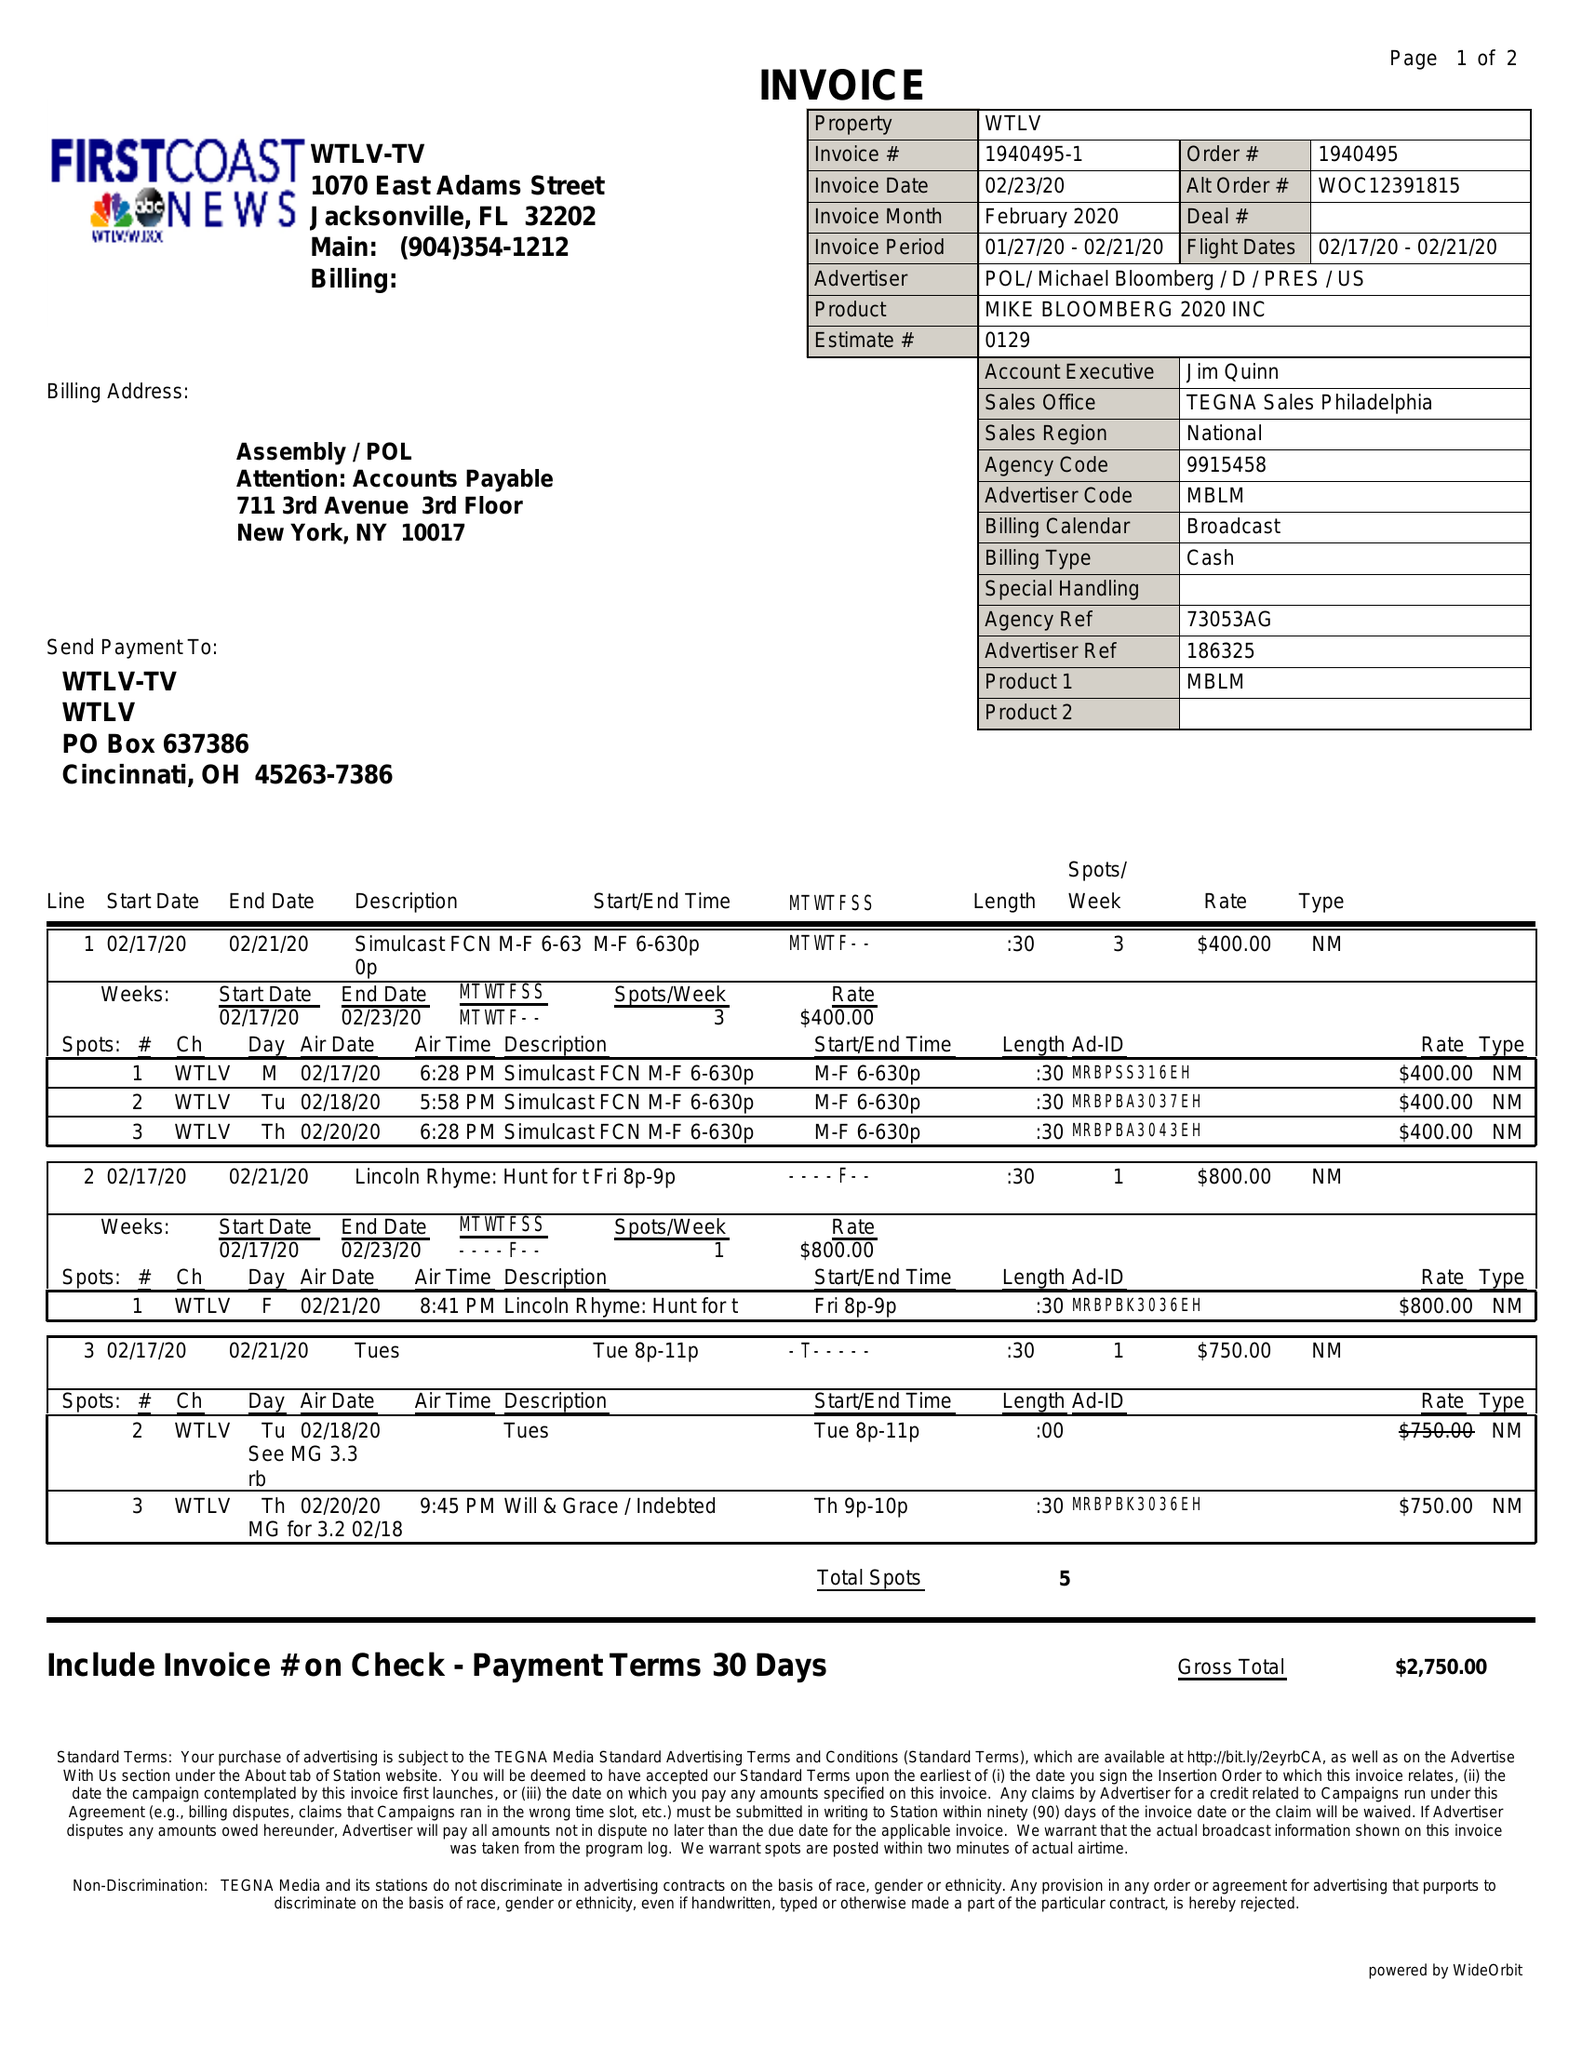What is the value for the flight_to?
Answer the question using a single word or phrase. 02/21/20 